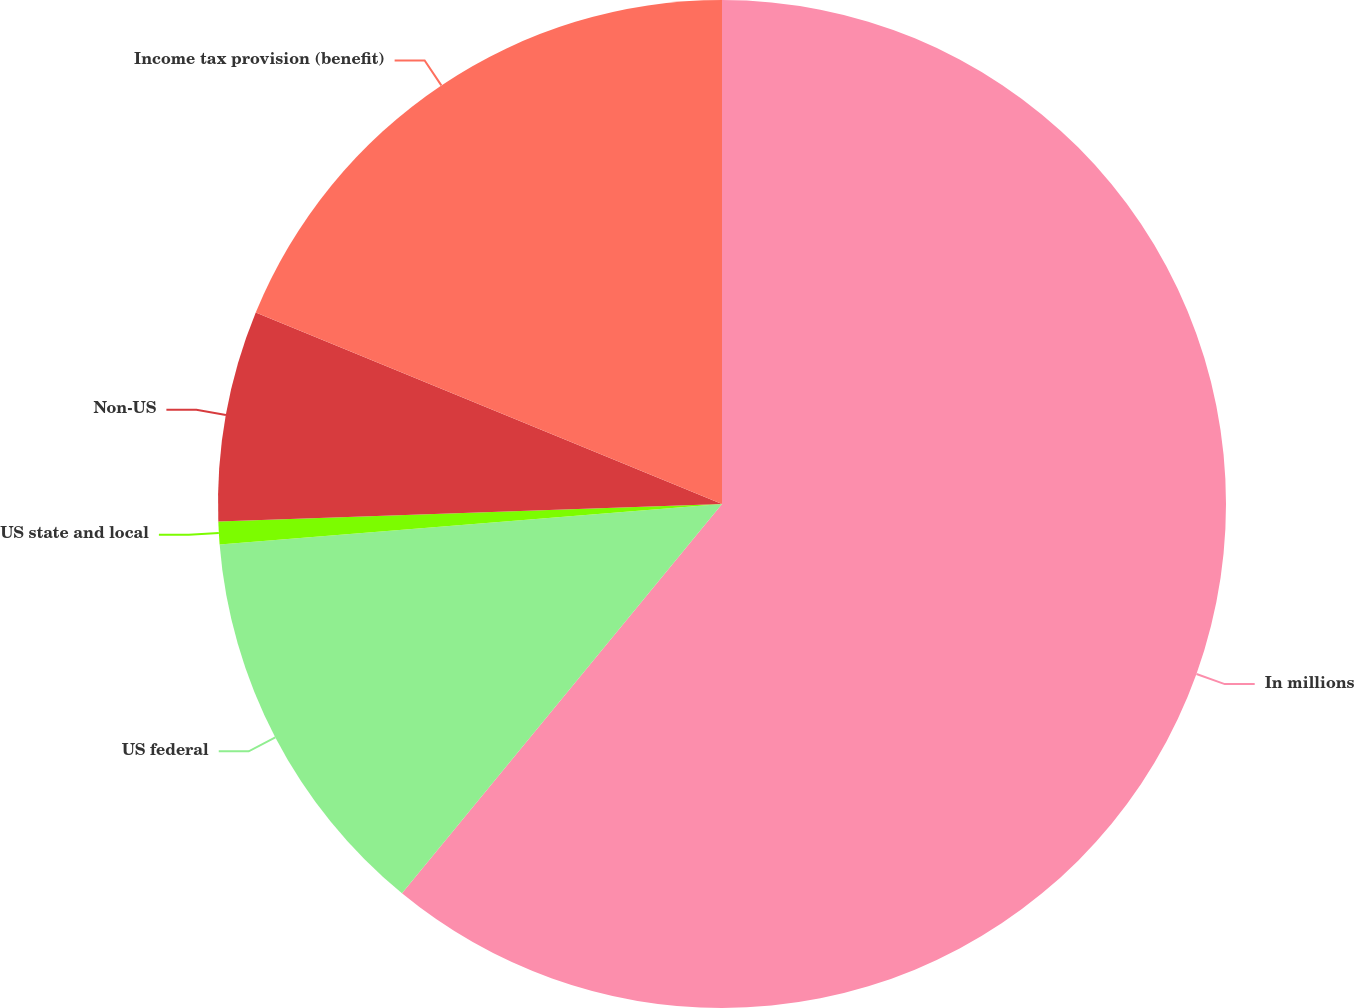Convert chart. <chart><loc_0><loc_0><loc_500><loc_500><pie_chart><fcel>In millions<fcel>US federal<fcel>US state and local<fcel>Non-US<fcel>Income tax provision (benefit)<nl><fcel>60.95%<fcel>12.77%<fcel>0.73%<fcel>6.75%<fcel>18.8%<nl></chart> 